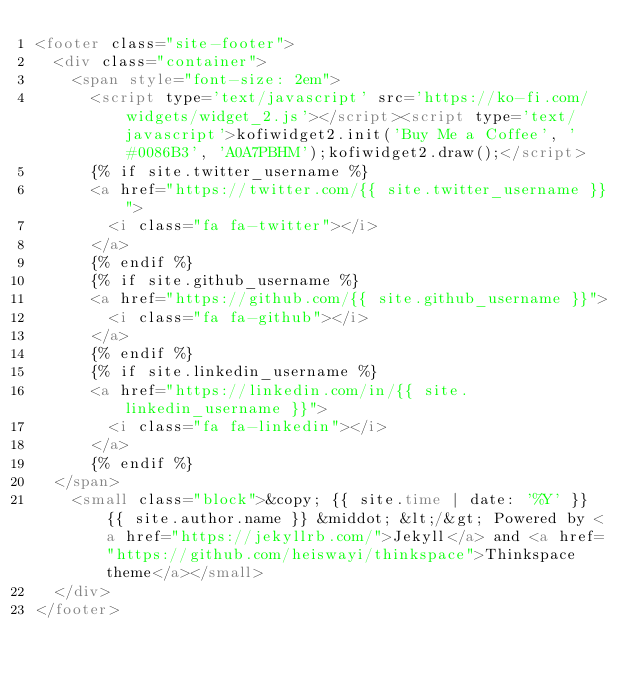<code> <loc_0><loc_0><loc_500><loc_500><_HTML_><footer class="site-footer">
  <div class="container">
    <span style="font-size: 2em">
      <script type='text/javascript' src='https://ko-fi.com/widgets/widget_2.js'></script><script type='text/javascript'>kofiwidget2.init('Buy Me a Coffee', '#0086B3', 'A0A7PBHM');kofiwidget2.draw();</script> 
      {% if site.twitter_username %}
      <a href="https://twitter.com/{{ site.twitter_username }}">
        <i class="fa fa-twitter"></i>
      </a>
      {% endif %}
      {% if site.github_username %}
      <a href="https://github.com/{{ site.github_username }}">
        <i class="fa fa-github"></i>
      </a>
      {% endif %}
      {% if site.linkedin_username %}
      <a href="https://linkedin.com/in/{{ site.linkedin_username }}">
        <i class="fa fa-linkedin"></i>
      </a>
      {% endif %}
  </span>
    <small class="block">&copy; {{ site.time | date: '%Y' }} {{ site.author.name }} &middot; &lt;/&gt; Powered by <a href="https://jekyllrb.com/">Jekyll</a> and <a href="https://github.com/heiswayi/thinkspace">Thinkspace theme</a></small>
  </div>
</footer>
</code> 